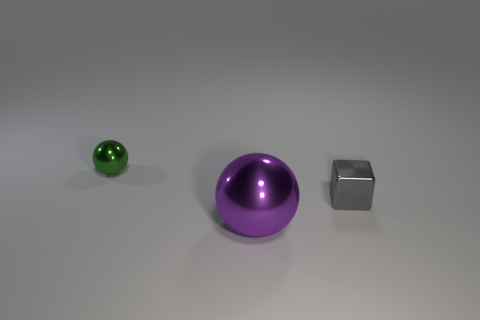How many cylinders are red things or tiny metallic things?
Your response must be concise. 0. There is another object that is the same shape as the green shiny object; what is its material?
Offer a very short reply. Metal. There is a green sphere that is made of the same material as the cube; what size is it?
Offer a very short reply. Small. There is a tiny thing that is right of the big purple shiny object; is its shape the same as the small shiny thing that is left of the large thing?
Your response must be concise. No. The small sphere that is made of the same material as the large purple sphere is what color?
Offer a very short reply. Green. Is the size of the metallic object that is to the left of the purple ball the same as the metallic sphere in front of the gray metallic block?
Offer a terse response. No. What shape is the thing that is right of the small green ball and to the left of the block?
Give a very brief answer. Sphere. Is there a tiny yellow cylinder that has the same material as the tiny green object?
Make the answer very short. No. Is the sphere right of the tiny metal ball made of the same material as the object behind the block?
Make the answer very short. Yes. Is the number of spheres greater than the number of gray blocks?
Make the answer very short. Yes. 